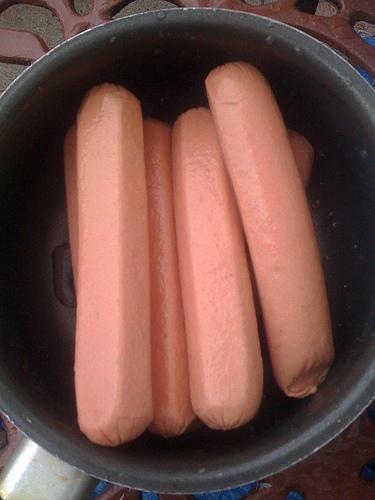How many hot dogs in the pot?
Give a very brief answer. 6. 